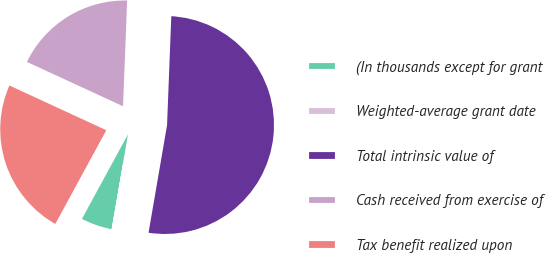Convert chart to OTSL. <chart><loc_0><loc_0><loc_500><loc_500><pie_chart><fcel>(In thousands except for grant<fcel>Weighted-average grant date<fcel>Total intrinsic value of<fcel>Cash received from exercise of<fcel>Tax benefit realized upon<nl><fcel>5.21%<fcel>0.01%<fcel>52.1%<fcel>18.74%<fcel>23.95%<nl></chart> 